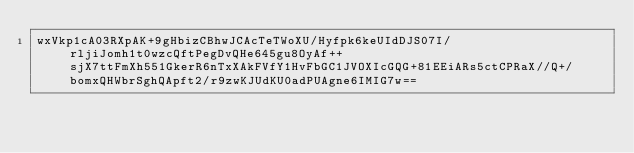Convert code to text. <code><loc_0><loc_0><loc_500><loc_500><_SML_>wxVkp1cA03RXpAK+9gHbizCBhwJCAcTeTWoXU/Hyfpk6keUIdDJS07I/rljiJomh1t0wzcQftPegDvQHe645gu8OyAf++sjX7ttFmXh551GkerR6nTxXAkFVfY1HvFbGC1JVOXIcGQG+81EEiARs5ctCPRaX//Q+/bomxQHWbrSghQApft2/r9zwKJUdKU0adPUAgne6IMIG7w==</code> 